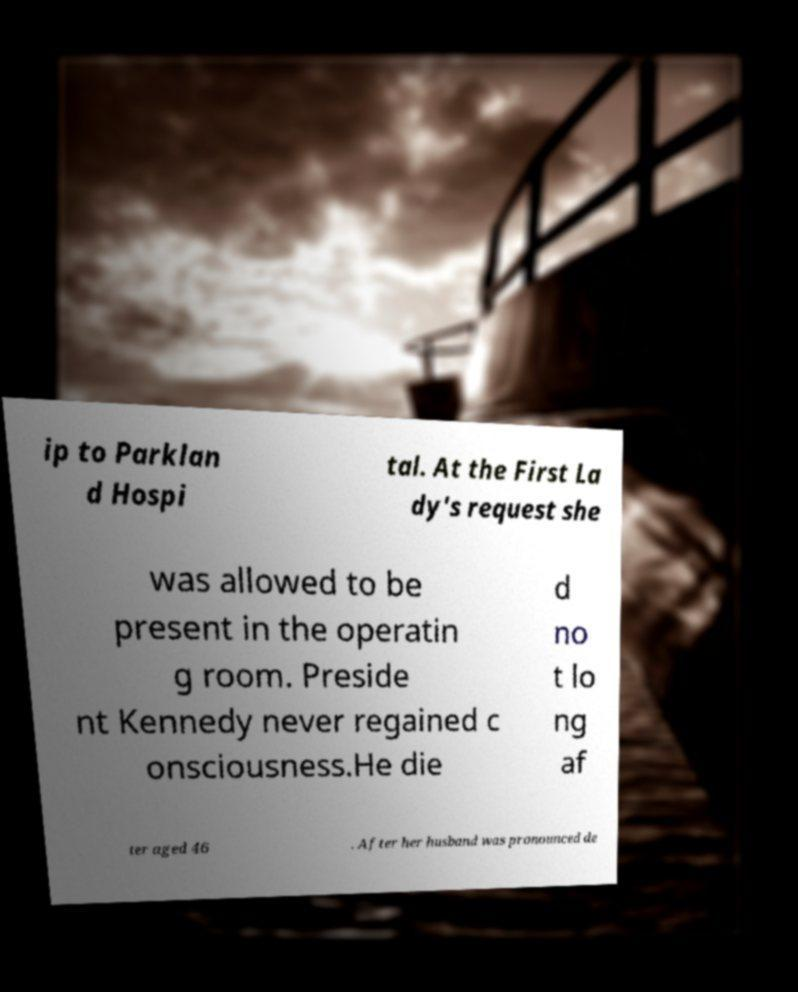There's text embedded in this image that I need extracted. Can you transcribe it verbatim? ip to Parklan d Hospi tal. At the First La dy's request she was allowed to be present in the operatin g room. Preside nt Kennedy never regained c onsciousness.He die d no t lo ng af ter aged 46 . After her husband was pronounced de 